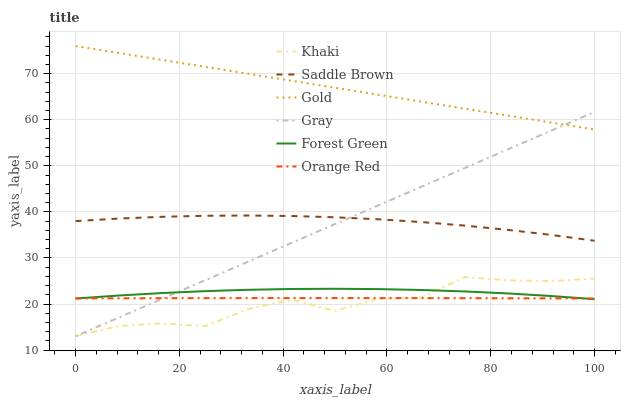Does Khaki have the minimum area under the curve?
Answer yes or no. Yes. Does Gold have the maximum area under the curve?
Answer yes or no. Yes. Does Gold have the minimum area under the curve?
Answer yes or no. No. Does Khaki have the maximum area under the curve?
Answer yes or no. No. Is Gray the smoothest?
Answer yes or no. Yes. Is Khaki the roughest?
Answer yes or no. Yes. Is Gold the smoothest?
Answer yes or no. No. Is Gold the roughest?
Answer yes or no. No. Does Gray have the lowest value?
Answer yes or no. Yes. Does Gold have the lowest value?
Answer yes or no. No. Does Gold have the highest value?
Answer yes or no. Yes. Does Khaki have the highest value?
Answer yes or no. No. Is Saddle Brown less than Gold?
Answer yes or no. Yes. Is Saddle Brown greater than Khaki?
Answer yes or no. Yes. Does Gray intersect Forest Green?
Answer yes or no. Yes. Is Gray less than Forest Green?
Answer yes or no. No. Is Gray greater than Forest Green?
Answer yes or no. No. Does Saddle Brown intersect Gold?
Answer yes or no. No. 